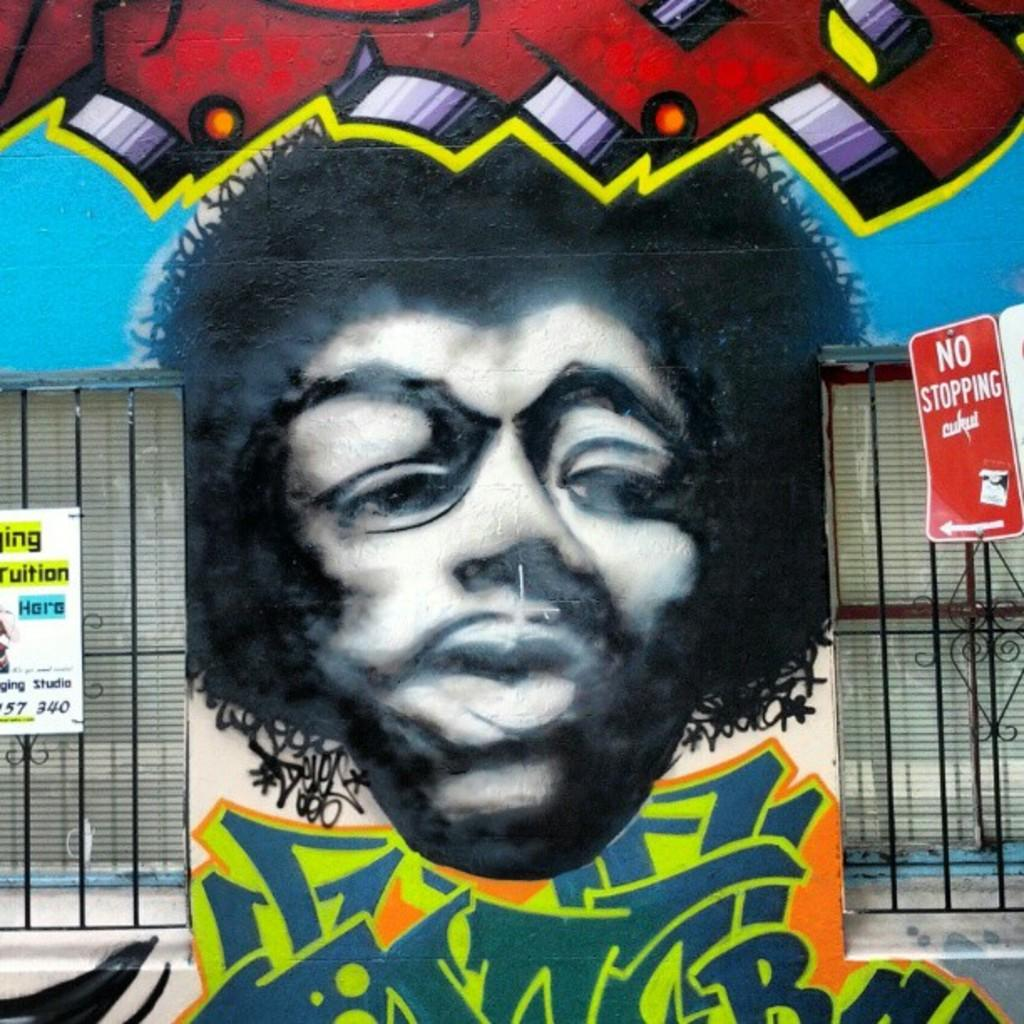What is the main subject in the center of the image? There is a graphic painting in the center of the image. What is located beside the painting? There is a sign board beside the painting. What other types of boards can be seen in the image? There are name boards in the image. What kind of fence is visible in the image? There is a metal rod fence in the image. Can you see a rabbit playing with a match in the image? No, there is no rabbit or match present in the image. Where is the kitty hiding in the image? There is no kitty present in the image. 